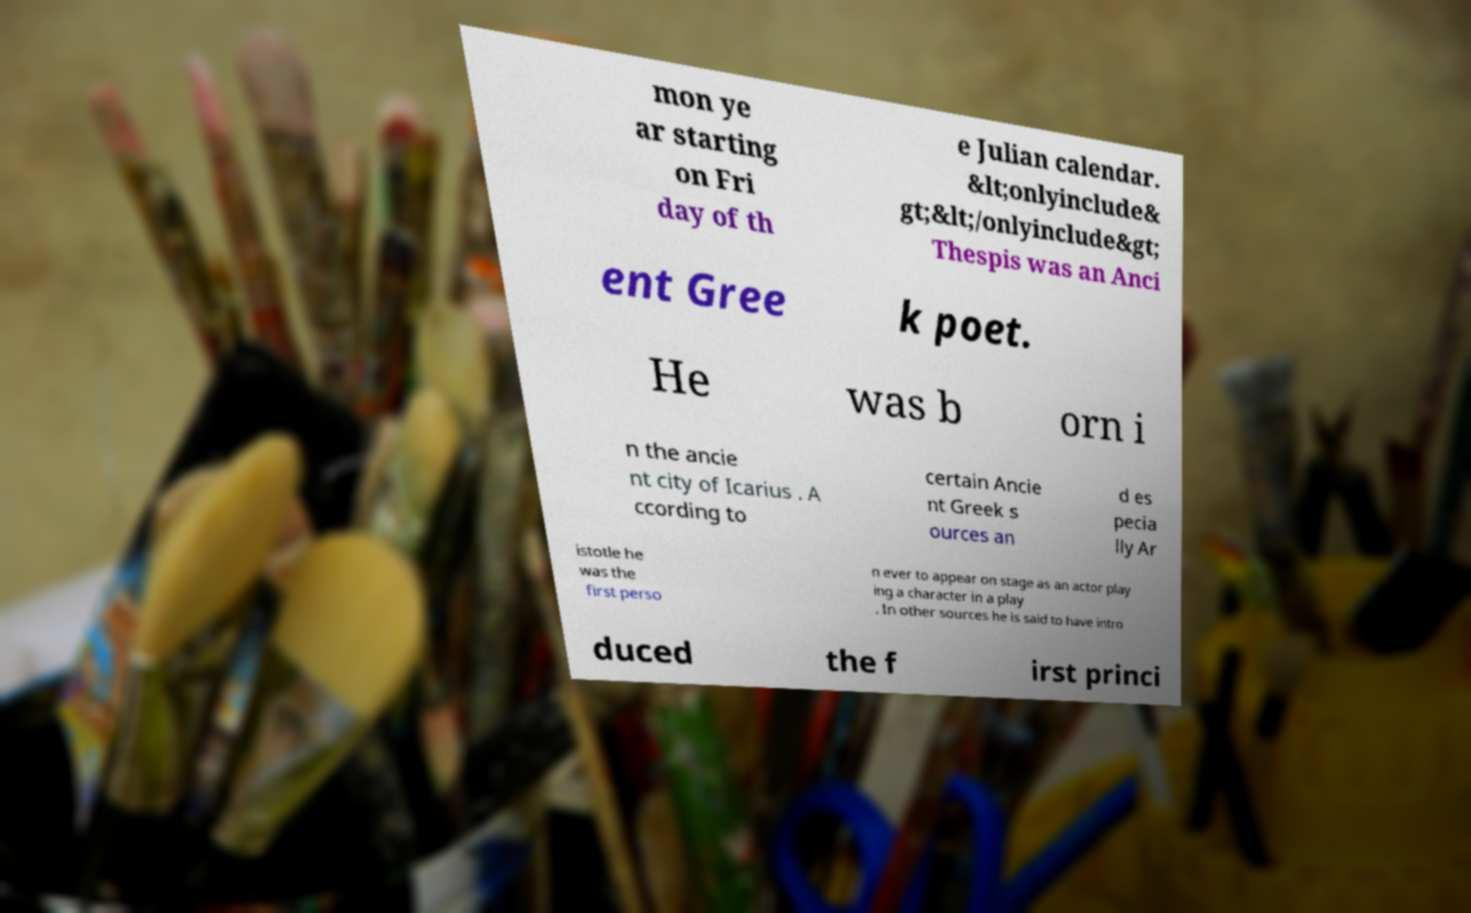What messages or text are displayed in this image? I need them in a readable, typed format. mon ye ar starting on Fri day of th e Julian calendar. &lt;onlyinclude& gt;&lt;/onlyinclude&gt; Thespis was an Anci ent Gree k poet. He was b orn i n the ancie nt city of Icarius . A ccording to certain Ancie nt Greek s ources an d es pecia lly Ar istotle he was the first perso n ever to appear on stage as an actor play ing a character in a play . In other sources he is said to have intro duced the f irst princi 